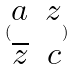<formula> <loc_0><loc_0><loc_500><loc_500>( \begin{matrix} a & z \\ \overline { z } & c \end{matrix} )</formula> 